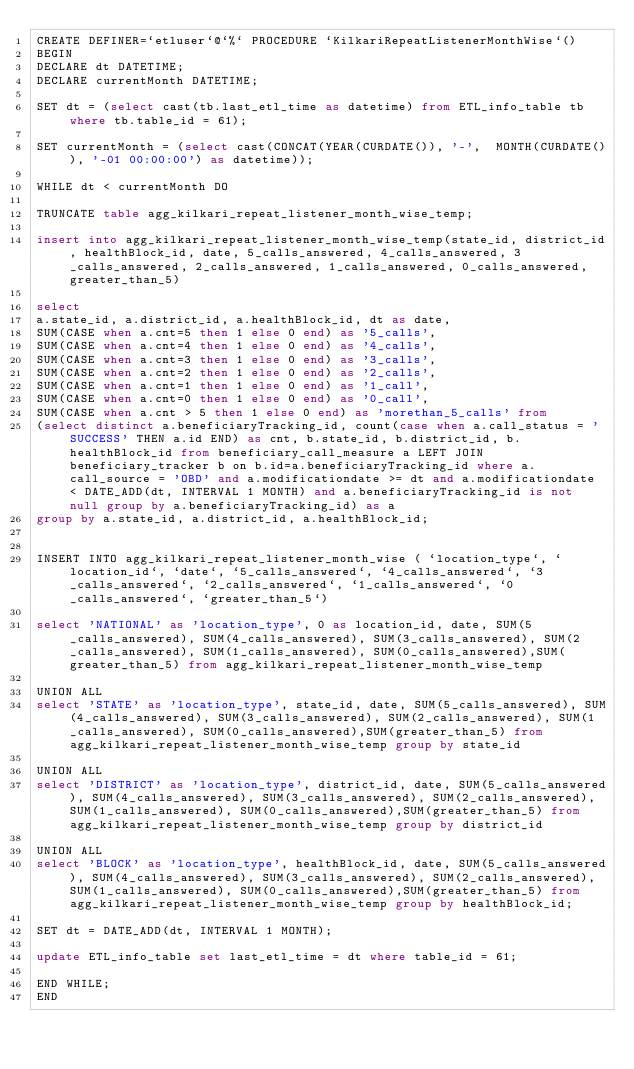Convert code to text. <code><loc_0><loc_0><loc_500><loc_500><_SQL_>CREATE DEFINER=`etluser`@`%` PROCEDURE `KilkariRepeatListenerMonthWise`()
BEGIN
DECLARE dt DATETIME;
DECLARE currentMonth DATETIME;

SET dt = (select cast(tb.last_etl_time as datetime) from ETL_info_table tb where tb.table_id = 61);

SET currentMonth = (select cast(CONCAT(YEAR(CURDATE()), '-',  MONTH(CURDATE()), '-01 00:00:00') as datetime));

WHILE dt < currentMonth DO

TRUNCATE table agg_kilkari_repeat_listener_month_wise_temp;

insert into agg_kilkari_repeat_listener_month_wise_temp(state_id, district_id, healthBlock_id, date, 5_calls_answered, 4_calls_answered, 3_calls_answered, 2_calls_answered, 1_calls_answered, 0_calls_answered, greater_than_5)

select 
a.state_id, a.district_id, a.healthBlock_id, dt as date, 
SUM(CASE when a.cnt=5 then 1 else 0 end) as '5_calls',
SUM(CASE when a.cnt=4 then 1 else 0 end) as '4_calls',
SUM(CASE when a.cnt=3 then 1 else 0 end) as '3_calls',
SUM(CASE when a.cnt=2 then 1 else 0 end) as '2_calls',
SUM(CASE when a.cnt=1 then 1 else 0 end) as '1_call',
SUM(CASE when a.cnt=0 then 1 else 0 end) as '0_call',
SUM(CASE when a.cnt > 5 then 1 else 0 end) as 'morethan_5_calls' from 
(select distinct a.beneficiaryTracking_id, count(case when a.call_status = 'SUCCESS' THEN a.id END) as cnt, b.state_id, b.district_id, b.healthBlock_id from beneficiary_call_measure a LEFT JOIN beneficiary_tracker b on b.id=a.beneficiaryTracking_id where a.call_source = 'OBD' and a.modificationdate >= dt and a.modificationdate < DATE_ADD(dt, INTERVAL 1 MONTH) and a.beneficiaryTracking_id is not null group by a.beneficiaryTracking_id) as a 
group by a.state_id, a.district_id, a.healthBlock_id;


INSERT INTO agg_kilkari_repeat_listener_month_wise ( `location_type`, `location_id`, `date`, `5_calls_answered`, `4_calls_answered`, `3_calls_answered`, `2_calls_answered`, `1_calls_answered`, `0_calls_answered`, `greater_than_5`)

select 'NATIONAL' as 'location_type', 0 as location_id, date, SUM(5_calls_answered), SUM(4_calls_answered), SUM(3_calls_answered), SUM(2_calls_answered), SUM(1_calls_answered), SUM(0_calls_answered),SUM(greater_than_5) from agg_kilkari_repeat_listener_month_wise_temp

UNION ALL
select 'STATE' as 'location_type', state_id, date, SUM(5_calls_answered), SUM(4_calls_answered), SUM(3_calls_answered), SUM(2_calls_answered), SUM(1_calls_answered), SUM(0_calls_answered),SUM(greater_than_5) from agg_kilkari_repeat_listener_month_wise_temp group by state_id

UNION ALL
select 'DISTRICT' as 'location_type', district_id, date, SUM(5_calls_answered), SUM(4_calls_answered), SUM(3_calls_answered), SUM(2_calls_answered), SUM(1_calls_answered), SUM(0_calls_answered),SUM(greater_than_5) from agg_kilkari_repeat_listener_month_wise_temp group by district_id

UNION ALL
select 'BLOCK' as 'location_type', healthBlock_id, date, SUM(5_calls_answered), SUM(4_calls_answered), SUM(3_calls_answered), SUM(2_calls_answered), SUM(1_calls_answered), SUM(0_calls_answered),SUM(greater_than_5) from agg_kilkari_repeat_listener_month_wise_temp group by healthBlock_id;

SET dt = DATE_ADD(dt, INTERVAL 1 MONTH);

update ETL_info_table set last_etl_time = dt where table_id = 61;
 
END WHILE;
END
</code> 